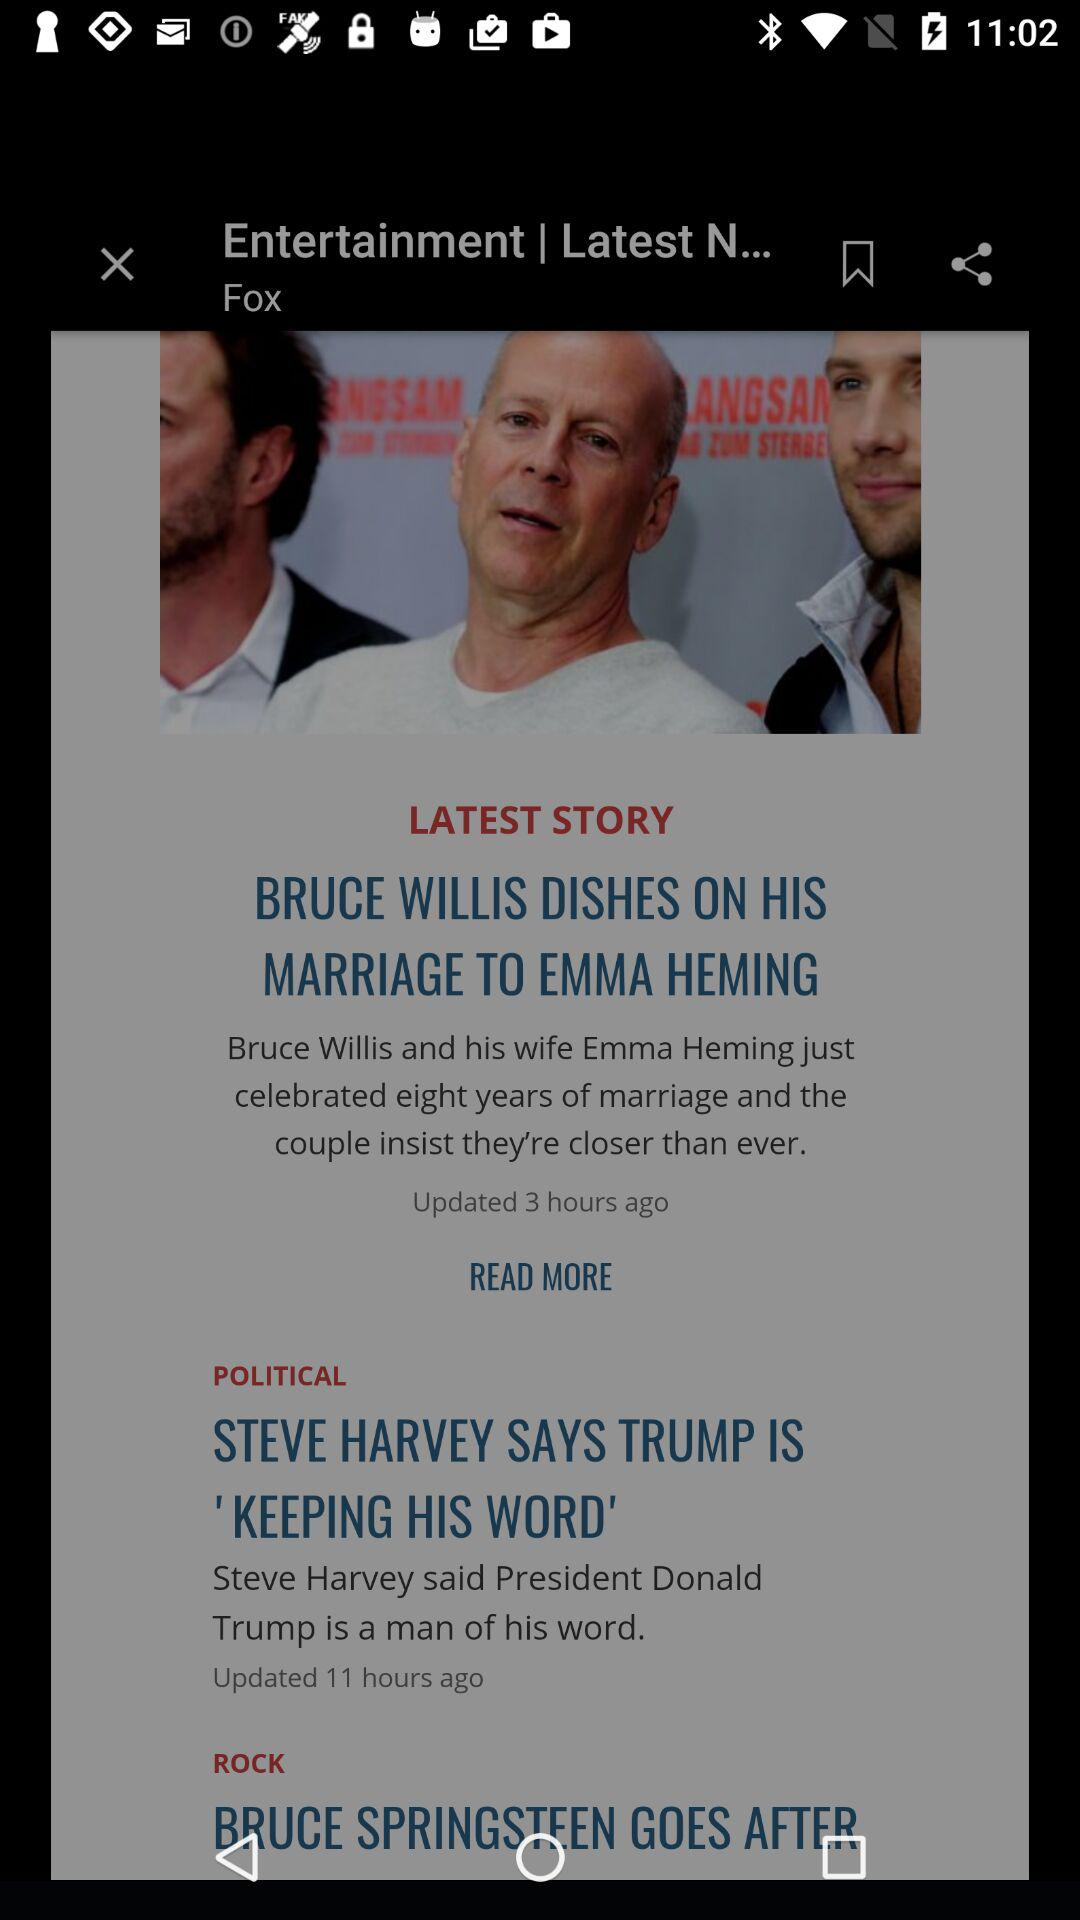How many hours ago was the last update for the Bruce Willis story?
Answer the question using a single word or phrase. 3 